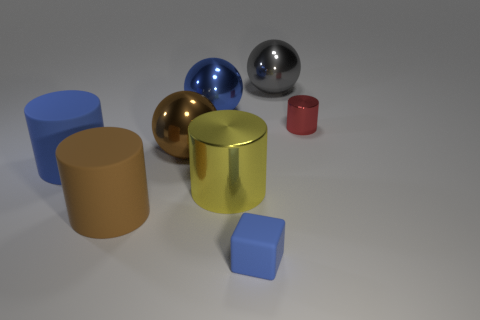Subtract all large gray balls. How many balls are left? 2 Subtract all blue cylinders. How many cylinders are left? 3 Add 2 small green rubber objects. How many objects exist? 10 Subtract 2 cylinders. How many cylinders are left? 2 Subtract all balls. How many objects are left? 5 Subtract all gray cylinders. Subtract all green cubes. How many cylinders are left? 4 Add 7 big brown shiny things. How many big brown shiny things are left? 8 Add 4 big green metallic spheres. How many big green metallic spheres exist? 4 Subtract 1 brown spheres. How many objects are left? 7 Subtract all big metal things. Subtract all gray shiny objects. How many objects are left? 3 